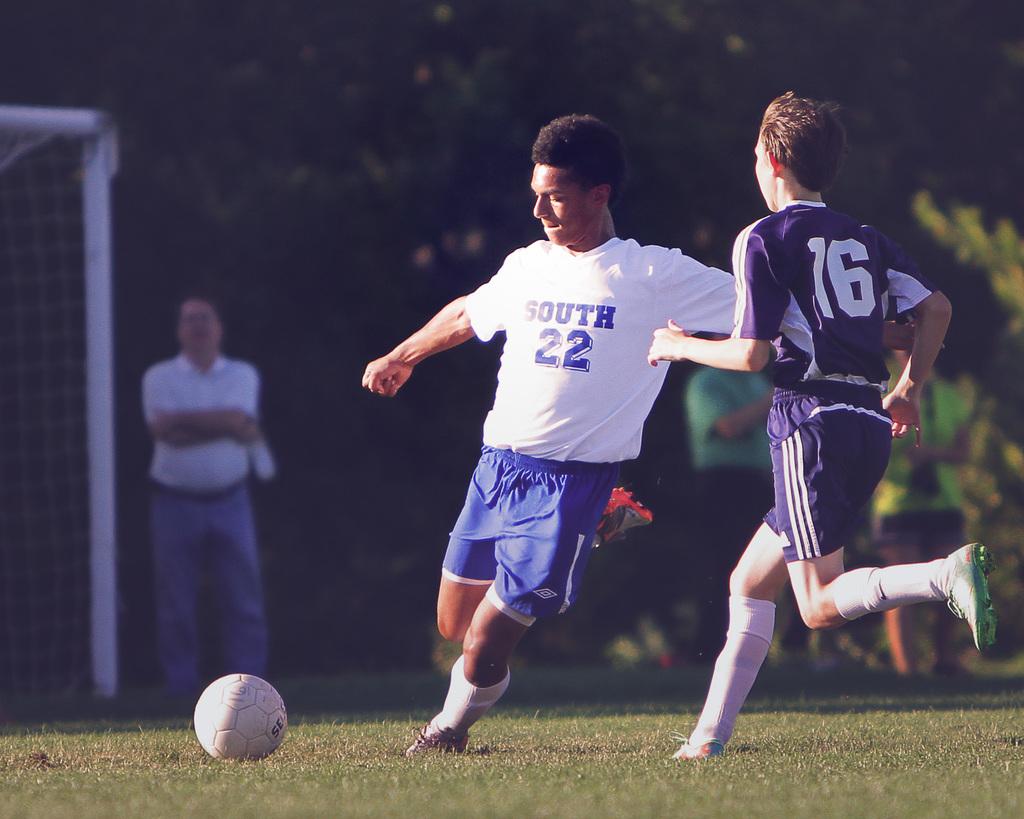What team player is player 16 trying to get the ball from?
Give a very brief answer. 22. What team player is player 22 avoiding?
Offer a terse response. 16. 